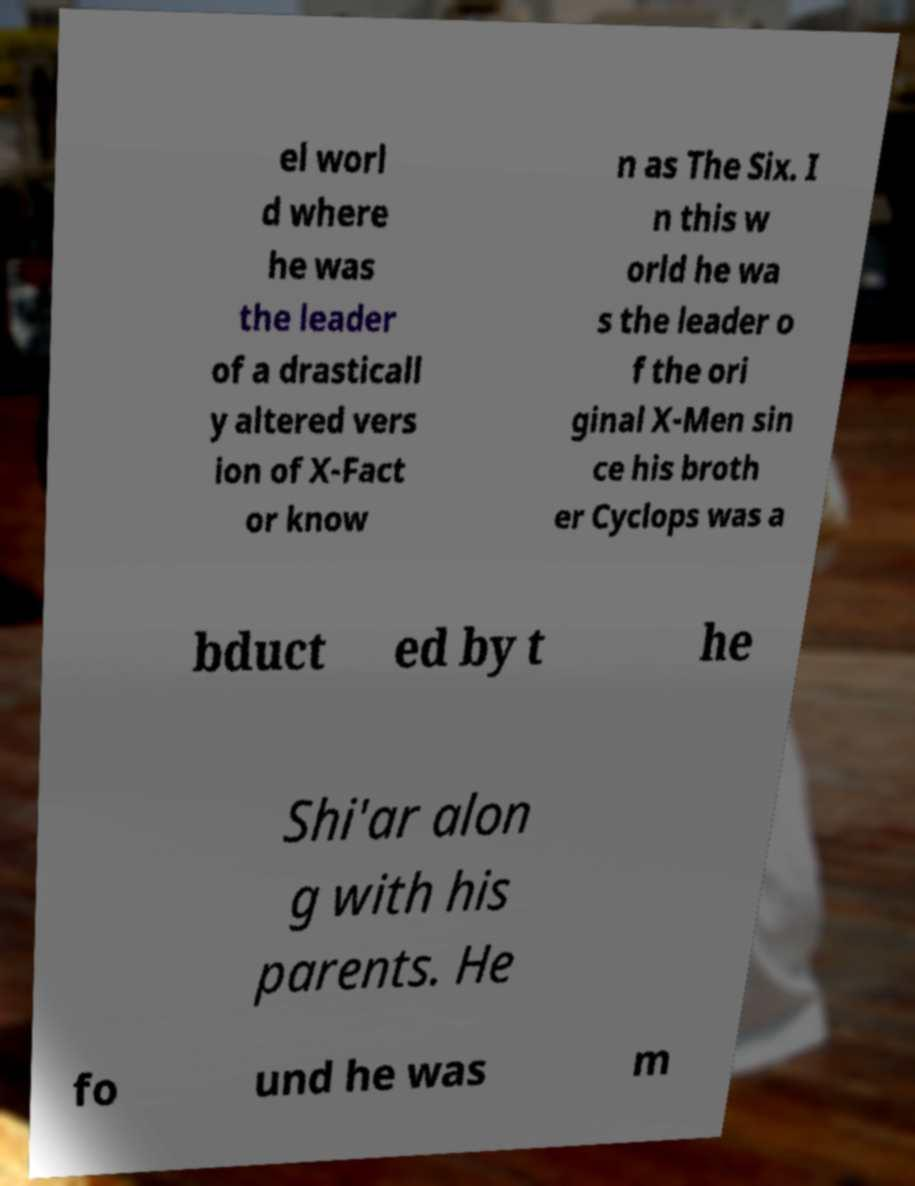Could you extract and type out the text from this image? el worl d where he was the leader of a drasticall y altered vers ion of X-Fact or know n as The Six. I n this w orld he wa s the leader o f the ori ginal X-Men sin ce his broth er Cyclops was a bduct ed by t he Shi'ar alon g with his parents. He fo und he was m 